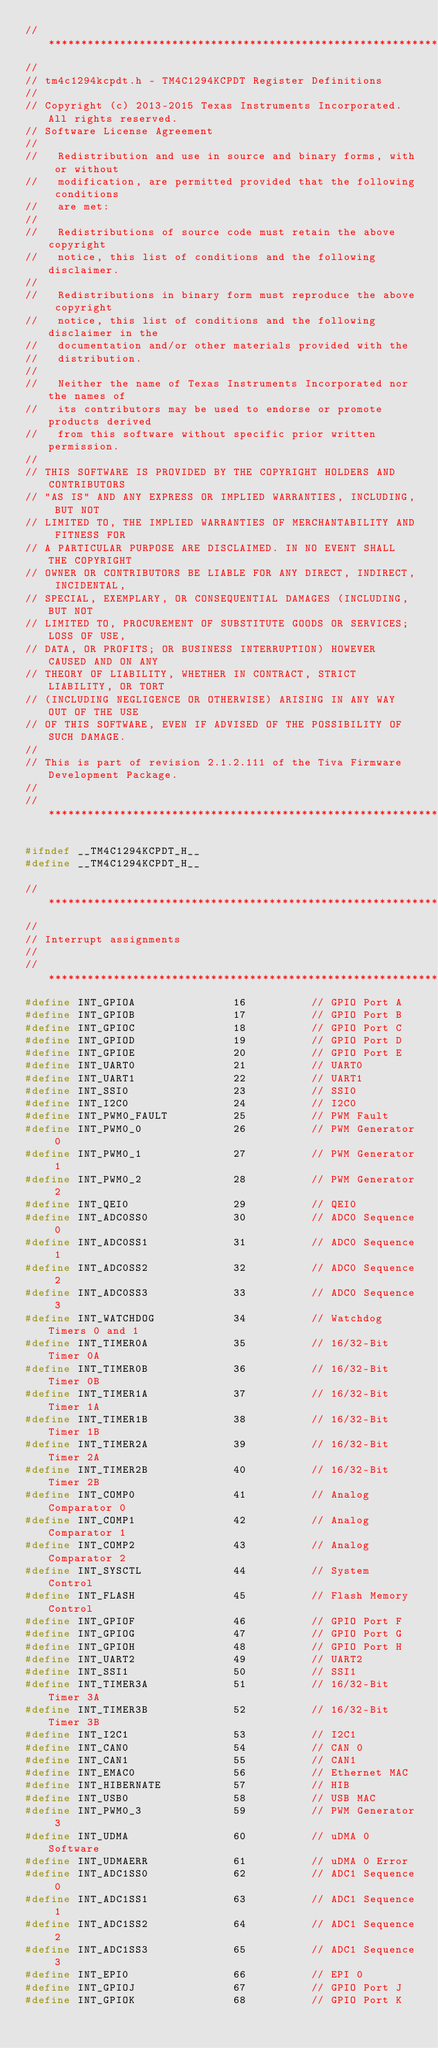Convert code to text. <code><loc_0><loc_0><loc_500><loc_500><_C_>//*****************************************************************************
//
// tm4c1294kcpdt.h - TM4C1294KCPDT Register Definitions
//
// Copyright (c) 2013-2015 Texas Instruments Incorporated.  All rights reserved.
// Software License Agreement
// 
//   Redistribution and use in source and binary forms, with or without
//   modification, are permitted provided that the following conditions
//   are met:
// 
//   Redistributions of source code must retain the above copyright
//   notice, this list of conditions and the following disclaimer.
// 
//   Redistributions in binary form must reproduce the above copyright
//   notice, this list of conditions and the following disclaimer in the
//   documentation and/or other materials provided with the  
//   distribution.
// 
//   Neither the name of Texas Instruments Incorporated nor the names of
//   its contributors may be used to endorse or promote products derived
//   from this software without specific prior written permission.
// 
// THIS SOFTWARE IS PROVIDED BY THE COPYRIGHT HOLDERS AND CONTRIBUTORS
// "AS IS" AND ANY EXPRESS OR IMPLIED WARRANTIES, INCLUDING, BUT NOT
// LIMITED TO, THE IMPLIED WARRANTIES OF MERCHANTABILITY AND FITNESS FOR
// A PARTICULAR PURPOSE ARE DISCLAIMED. IN NO EVENT SHALL THE COPYRIGHT
// OWNER OR CONTRIBUTORS BE LIABLE FOR ANY DIRECT, INDIRECT, INCIDENTAL,
// SPECIAL, EXEMPLARY, OR CONSEQUENTIAL DAMAGES (INCLUDING, BUT NOT
// LIMITED TO, PROCUREMENT OF SUBSTITUTE GOODS OR SERVICES; LOSS OF USE,
// DATA, OR PROFITS; OR BUSINESS INTERRUPTION) HOWEVER CAUSED AND ON ANY
// THEORY OF LIABILITY, WHETHER IN CONTRACT, STRICT LIABILITY, OR TORT
// (INCLUDING NEGLIGENCE OR OTHERWISE) ARISING IN ANY WAY OUT OF THE USE
// OF THIS SOFTWARE, EVEN IF ADVISED OF THE POSSIBILITY OF SUCH DAMAGE.
// 
// This is part of revision 2.1.2.111 of the Tiva Firmware Development Package.
//
//*****************************************************************************

#ifndef __TM4C1294KCPDT_H__
#define __TM4C1294KCPDT_H__

//*****************************************************************************
//
// Interrupt assignments
//
//*****************************************************************************
#define INT_GPIOA               16          // GPIO Port A
#define INT_GPIOB               17          // GPIO Port B
#define INT_GPIOC               18          // GPIO Port C
#define INT_GPIOD               19          // GPIO Port D
#define INT_GPIOE               20          // GPIO Port E
#define INT_UART0               21          // UART0
#define INT_UART1               22          // UART1
#define INT_SSI0                23          // SSI0
#define INT_I2C0                24          // I2C0
#define INT_PWM0_FAULT          25          // PWM Fault
#define INT_PWM0_0              26          // PWM Generator 0
#define INT_PWM0_1              27          // PWM Generator 1
#define INT_PWM0_2              28          // PWM Generator 2
#define INT_QEI0                29          // QEI0
#define INT_ADC0SS0             30          // ADC0 Sequence 0
#define INT_ADC0SS1             31          // ADC0 Sequence 1
#define INT_ADC0SS2             32          // ADC0 Sequence 2
#define INT_ADC0SS3             33          // ADC0 Sequence 3
#define INT_WATCHDOG            34          // Watchdog Timers 0 and 1
#define INT_TIMER0A             35          // 16/32-Bit Timer 0A
#define INT_TIMER0B             36          // 16/32-Bit Timer 0B
#define INT_TIMER1A             37          // 16/32-Bit Timer 1A
#define INT_TIMER1B             38          // 16/32-Bit Timer 1B
#define INT_TIMER2A             39          // 16/32-Bit Timer 2A
#define INT_TIMER2B             40          // 16/32-Bit Timer 2B
#define INT_COMP0               41          // Analog Comparator 0
#define INT_COMP1               42          // Analog Comparator 1
#define INT_COMP2               43          // Analog Comparator 2
#define INT_SYSCTL              44          // System Control
#define INT_FLASH               45          // Flash Memory Control
#define INT_GPIOF               46          // GPIO Port F
#define INT_GPIOG               47          // GPIO Port G
#define INT_GPIOH               48          // GPIO Port H
#define INT_UART2               49          // UART2
#define INT_SSI1                50          // SSI1
#define INT_TIMER3A             51          // 16/32-Bit Timer 3A
#define INT_TIMER3B             52          // 16/32-Bit Timer 3B
#define INT_I2C1                53          // I2C1
#define INT_CAN0                54          // CAN 0
#define INT_CAN1                55          // CAN1
#define INT_EMAC0               56          // Ethernet MAC
#define INT_HIBERNATE           57          // HIB
#define INT_USB0                58          // USB MAC
#define INT_PWM0_3              59          // PWM Generator 3
#define INT_UDMA                60          // uDMA 0 Software
#define INT_UDMAERR             61          // uDMA 0 Error
#define INT_ADC1SS0             62          // ADC1 Sequence 0
#define INT_ADC1SS1             63          // ADC1 Sequence 1
#define INT_ADC1SS2             64          // ADC1 Sequence 2
#define INT_ADC1SS3             65          // ADC1 Sequence 3
#define INT_EPI0                66          // EPI 0
#define INT_GPIOJ               67          // GPIO Port J
#define INT_GPIOK               68          // GPIO Port K</code> 